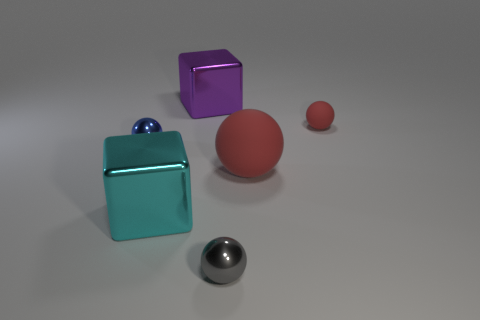There is a tiny gray thing that is made of the same material as the blue sphere; what is its shape?
Your answer should be compact. Sphere. Is the number of tiny shiny spheres that are to the right of the big purple object the same as the number of large red things?
Offer a terse response. Yes. Is the cube that is in front of the big purple metal object made of the same material as the big cube that is behind the small red sphere?
Give a very brief answer. Yes. There is a small metal object behind the red object that is in front of the small matte sphere; what is its shape?
Offer a terse response. Sphere. What is the color of the other block that is the same material as the purple cube?
Offer a terse response. Cyan. Is the color of the small rubber object the same as the large ball?
Ensure brevity in your answer.  Yes. What is the shape of the blue object that is the same size as the gray sphere?
Provide a short and direct response. Sphere. The purple thing has what size?
Your answer should be very brief. Large. There is a object that is on the left side of the cyan cube; is it the same size as the gray object in front of the cyan metal cube?
Ensure brevity in your answer.  Yes. What color is the tiny metallic thing left of the tiny shiny ball that is in front of the small blue metal sphere?
Your response must be concise. Blue. 